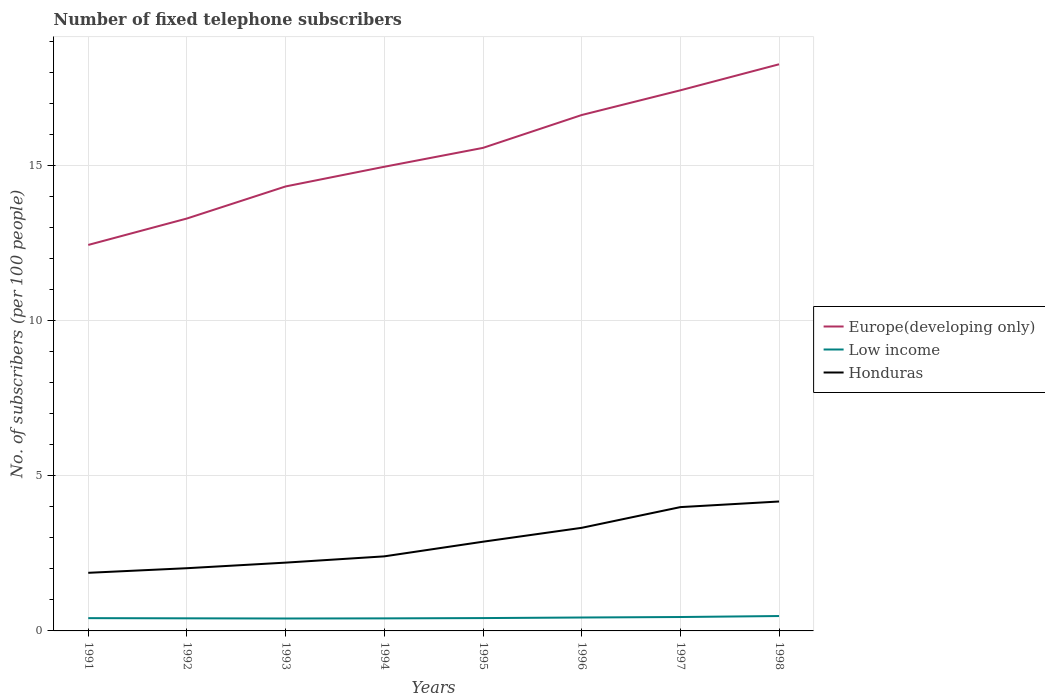How many different coloured lines are there?
Ensure brevity in your answer.  3. Does the line corresponding to Low income intersect with the line corresponding to Honduras?
Offer a terse response. No. Across all years, what is the maximum number of fixed telephone subscribers in Europe(developing only)?
Your answer should be very brief. 12.44. In which year was the number of fixed telephone subscribers in Europe(developing only) maximum?
Give a very brief answer. 1991. What is the total number of fixed telephone subscribers in Low income in the graph?
Ensure brevity in your answer.  -0. What is the difference between the highest and the second highest number of fixed telephone subscribers in Low income?
Ensure brevity in your answer.  0.08. What is the difference between the highest and the lowest number of fixed telephone subscribers in Low income?
Your answer should be compact. 3. Is the number of fixed telephone subscribers in Europe(developing only) strictly greater than the number of fixed telephone subscribers in Honduras over the years?
Offer a terse response. No. Are the values on the major ticks of Y-axis written in scientific E-notation?
Offer a terse response. No. Does the graph contain grids?
Give a very brief answer. Yes. How many legend labels are there?
Ensure brevity in your answer.  3. How are the legend labels stacked?
Ensure brevity in your answer.  Vertical. What is the title of the graph?
Make the answer very short. Number of fixed telephone subscribers. Does "Burkina Faso" appear as one of the legend labels in the graph?
Your answer should be compact. No. What is the label or title of the X-axis?
Your response must be concise. Years. What is the label or title of the Y-axis?
Provide a short and direct response. No. of subscribers (per 100 people). What is the No. of subscribers (per 100 people) in Europe(developing only) in 1991?
Ensure brevity in your answer.  12.44. What is the No. of subscribers (per 100 people) of Low income in 1991?
Make the answer very short. 0.41. What is the No. of subscribers (per 100 people) of Honduras in 1991?
Ensure brevity in your answer.  1.87. What is the No. of subscribers (per 100 people) in Europe(developing only) in 1992?
Offer a very short reply. 13.29. What is the No. of subscribers (per 100 people) of Low income in 1992?
Give a very brief answer. 0.41. What is the No. of subscribers (per 100 people) of Honduras in 1992?
Give a very brief answer. 2.02. What is the No. of subscribers (per 100 people) of Europe(developing only) in 1993?
Offer a terse response. 14.33. What is the No. of subscribers (per 100 people) in Low income in 1993?
Ensure brevity in your answer.  0.4. What is the No. of subscribers (per 100 people) of Honduras in 1993?
Your answer should be compact. 2.2. What is the No. of subscribers (per 100 people) of Europe(developing only) in 1994?
Your response must be concise. 14.96. What is the No. of subscribers (per 100 people) in Low income in 1994?
Provide a succinct answer. 0.4. What is the No. of subscribers (per 100 people) in Honduras in 1994?
Keep it short and to the point. 2.4. What is the No. of subscribers (per 100 people) in Europe(developing only) in 1995?
Make the answer very short. 15.57. What is the No. of subscribers (per 100 people) of Low income in 1995?
Make the answer very short. 0.41. What is the No. of subscribers (per 100 people) in Honduras in 1995?
Give a very brief answer. 2.88. What is the No. of subscribers (per 100 people) of Europe(developing only) in 1996?
Your response must be concise. 16.63. What is the No. of subscribers (per 100 people) in Low income in 1996?
Make the answer very short. 0.43. What is the No. of subscribers (per 100 people) of Honduras in 1996?
Provide a succinct answer. 3.32. What is the No. of subscribers (per 100 people) of Europe(developing only) in 1997?
Your answer should be compact. 17.43. What is the No. of subscribers (per 100 people) in Low income in 1997?
Ensure brevity in your answer.  0.45. What is the No. of subscribers (per 100 people) of Honduras in 1997?
Offer a terse response. 3.99. What is the No. of subscribers (per 100 people) of Europe(developing only) in 1998?
Provide a short and direct response. 18.27. What is the No. of subscribers (per 100 people) in Low income in 1998?
Provide a succinct answer. 0.48. What is the No. of subscribers (per 100 people) of Honduras in 1998?
Provide a succinct answer. 4.17. Across all years, what is the maximum No. of subscribers (per 100 people) in Europe(developing only)?
Give a very brief answer. 18.27. Across all years, what is the maximum No. of subscribers (per 100 people) in Low income?
Make the answer very short. 0.48. Across all years, what is the maximum No. of subscribers (per 100 people) in Honduras?
Your answer should be compact. 4.17. Across all years, what is the minimum No. of subscribers (per 100 people) of Europe(developing only)?
Ensure brevity in your answer.  12.44. Across all years, what is the minimum No. of subscribers (per 100 people) in Low income?
Keep it short and to the point. 0.4. Across all years, what is the minimum No. of subscribers (per 100 people) in Honduras?
Keep it short and to the point. 1.87. What is the total No. of subscribers (per 100 people) in Europe(developing only) in the graph?
Offer a very short reply. 122.92. What is the total No. of subscribers (per 100 people) in Low income in the graph?
Your response must be concise. 3.4. What is the total No. of subscribers (per 100 people) of Honduras in the graph?
Make the answer very short. 22.86. What is the difference between the No. of subscribers (per 100 people) of Europe(developing only) in 1991 and that in 1992?
Keep it short and to the point. -0.85. What is the difference between the No. of subscribers (per 100 people) of Low income in 1991 and that in 1992?
Offer a terse response. 0.01. What is the difference between the No. of subscribers (per 100 people) in Honduras in 1991 and that in 1992?
Your response must be concise. -0.15. What is the difference between the No. of subscribers (per 100 people) in Europe(developing only) in 1991 and that in 1993?
Provide a succinct answer. -1.89. What is the difference between the No. of subscribers (per 100 people) in Low income in 1991 and that in 1993?
Offer a terse response. 0.01. What is the difference between the No. of subscribers (per 100 people) of Honduras in 1991 and that in 1993?
Provide a succinct answer. -0.33. What is the difference between the No. of subscribers (per 100 people) of Europe(developing only) in 1991 and that in 1994?
Make the answer very short. -2.52. What is the difference between the No. of subscribers (per 100 people) in Low income in 1991 and that in 1994?
Your answer should be compact. 0.01. What is the difference between the No. of subscribers (per 100 people) of Honduras in 1991 and that in 1994?
Provide a short and direct response. -0.53. What is the difference between the No. of subscribers (per 100 people) of Europe(developing only) in 1991 and that in 1995?
Ensure brevity in your answer.  -3.13. What is the difference between the No. of subscribers (per 100 people) of Low income in 1991 and that in 1995?
Offer a terse response. -0. What is the difference between the No. of subscribers (per 100 people) in Honduras in 1991 and that in 1995?
Your response must be concise. -1. What is the difference between the No. of subscribers (per 100 people) in Europe(developing only) in 1991 and that in 1996?
Give a very brief answer. -4.19. What is the difference between the No. of subscribers (per 100 people) in Low income in 1991 and that in 1996?
Offer a terse response. -0.02. What is the difference between the No. of subscribers (per 100 people) in Honduras in 1991 and that in 1996?
Keep it short and to the point. -1.45. What is the difference between the No. of subscribers (per 100 people) in Europe(developing only) in 1991 and that in 1997?
Make the answer very short. -4.98. What is the difference between the No. of subscribers (per 100 people) of Low income in 1991 and that in 1997?
Keep it short and to the point. -0.04. What is the difference between the No. of subscribers (per 100 people) in Honduras in 1991 and that in 1997?
Provide a succinct answer. -2.12. What is the difference between the No. of subscribers (per 100 people) in Europe(developing only) in 1991 and that in 1998?
Offer a terse response. -5.82. What is the difference between the No. of subscribers (per 100 people) of Low income in 1991 and that in 1998?
Give a very brief answer. -0.07. What is the difference between the No. of subscribers (per 100 people) of Honduras in 1991 and that in 1998?
Keep it short and to the point. -2.3. What is the difference between the No. of subscribers (per 100 people) of Europe(developing only) in 1992 and that in 1993?
Give a very brief answer. -1.03. What is the difference between the No. of subscribers (per 100 people) in Low income in 1992 and that in 1993?
Provide a succinct answer. 0.01. What is the difference between the No. of subscribers (per 100 people) of Honduras in 1992 and that in 1993?
Offer a terse response. -0.18. What is the difference between the No. of subscribers (per 100 people) of Europe(developing only) in 1992 and that in 1994?
Provide a short and direct response. -1.67. What is the difference between the No. of subscribers (per 100 people) in Low income in 1992 and that in 1994?
Keep it short and to the point. 0. What is the difference between the No. of subscribers (per 100 people) in Honduras in 1992 and that in 1994?
Your answer should be compact. -0.38. What is the difference between the No. of subscribers (per 100 people) of Europe(developing only) in 1992 and that in 1995?
Your response must be concise. -2.28. What is the difference between the No. of subscribers (per 100 people) of Low income in 1992 and that in 1995?
Provide a succinct answer. -0.01. What is the difference between the No. of subscribers (per 100 people) of Honduras in 1992 and that in 1995?
Your answer should be compact. -0.85. What is the difference between the No. of subscribers (per 100 people) of Europe(developing only) in 1992 and that in 1996?
Make the answer very short. -3.34. What is the difference between the No. of subscribers (per 100 people) in Low income in 1992 and that in 1996?
Your answer should be very brief. -0.03. What is the difference between the No. of subscribers (per 100 people) in Honduras in 1992 and that in 1996?
Offer a very short reply. -1.3. What is the difference between the No. of subscribers (per 100 people) in Europe(developing only) in 1992 and that in 1997?
Ensure brevity in your answer.  -4.13. What is the difference between the No. of subscribers (per 100 people) of Low income in 1992 and that in 1997?
Provide a short and direct response. -0.04. What is the difference between the No. of subscribers (per 100 people) in Honduras in 1992 and that in 1997?
Give a very brief answer. -1.97. What is the difference between the No. of subscribers (per 100 people) of Europe(developing only) in 1992 and that in 1998?
Provide a short and direct response. -4.97. What is the difference between the No. of subscribers (per 100 people) of Low income in 1992 and that in 1998?
Your answer should be compact. -0.07. What is the difference between the No. of subscribers (per 100 people) in Honduras in 1992 and that in 1998?
Provide a short and direct response. -2.15. What is the difference between the No. of subscribers (per 100 people) of Europe(developing only) in 1993 and that in 1994?
Keep it short and to the point. -0.63. What is the difference between the No. of subscribers (per 100 people) of Low income in 1993 and that in 1994?
Your answer should be compact. -0. What is the difference between the No. of subscribers (per 100 people) in Honduras in 1993 and that in 1994?
Give a very brief answer. -0.2. What is the difference between the No. of subscribers (per 100 people) of Europe(developing only) in 1993 and that in 1995?
Your response must be concise. -1.24. What is the difference between the No. of subscribers (per 100 people) of Low income in 1993 and that in 1995?
Make the answer very short. -0.01. What is the difference between the No. of subscribers (per 100 people) in Honduras in 1993 and that in 1995?
Your answer should be very brief. -0.67. What is the difference between the No. of subscribers (per 100 people) of Europe(developing only) in 1993 and that in 1996?
Your response must be concise. -2.3. What is the difference between the No. of subscribers (per 100 people) in Low income in 1993 and that in 1996?
Your answer should be very brief. -0.03. What is the difference between the No. of subscribers (per 100 people) of Honduras in 1993 and that in 1996?
Provide a short and direct response. -1.12. What is the difference between the No. of subscribers (per 100 people) in Europe(developing only) in 1993 and that in 1997?
Offer a terse response. -3.1. What is the difference between the No. of subscribers (per 100 people) in Low income in 1993 and that in 1997?
Your answer should be very brief. -0.05. What is the difference between the No. of subscribers (per 100 people) of Honduras in 1993 and that in 1997?
Provide a short and direct response. -1.79. What is the difference between the No. of subscribers (per 100 people) of Europe(developing only) in 1993 and that in 1998?
Provide a short and direct response. -3.94. What is the difference between the No. of subscribers (per 100 people) in Low income in 1993 and that in 1998?
Offer a terse response. -0.08. What is the difference between the No. of subscribers (per 100 people) in Honduras in 1993 and that in 1998?
Keep it short and to the point. -1.97. What is the difference between the No. of subscribers (per 100 people) in Europe(developing only) in 1994 and that in 1995?
Your answer should be very brief. -0.61. What is the difference between the No. of subscribers (per 100 people) of Low income in 1994 and that in 1995?
Provide a succinct answer. -0.01. What is the difference between the No. of subscribers (per 100 people) in Honduras in 1994 and that in 1995?
Provide a succinct answer. -0.47. What is the difference between the No. of subscribers (per 100 people) in Europe(developing only) in 1994 and that in 1996?
Offer a very short reply. -1.67. What is the difference between the No. of subscribers (per 100 people) of Low income in 1994 and that in 1996?
Ensure brevity in your answer.  -0.03. What is the difference between the No. of subscribers (per 100 people) of Honduras in 1994 and that in 1996?
Keep it short and to the point. -0.92. What is the difference between the No. of subscribers (per 100 people) of Europe(developing only) in 1994 and that in 1997?
Your response must be concise. -2.46. What is the difference between the No. of subscribers (per 100 people) of Low income in 1994 and that in 1997?
Your answer should be compact. -0.04. What is the difference between the No. of subscribers (per 100 people) in Honduras in 1994 and that in 1997?
Provide a succinct answer. -1.59. What is the difference between the No. of subscribers (per 100 people) of Europe(developing only) in 1994 and that in 1998?
Your answer should be compact. -3.3. What is the difference between the No. of subscribers (per 100 people) in Low income in 1994 and that in 1998?
Provide a succinct answer. -0.08. What is the difference between the No. of subscribers (per 100 people) in Honduras in 1994 and that in 1998?
Offer a terse response. -1.77. What is the difference between the No. of subscribers (per 100 people) of Europe(developing only) in 1995 and that in 1996?
Your answer should be very brief. -1.06. What is the difference between the No. of subscribers (per 100 people) in Low income in 1995 and that in 1996?
Keep it short and to the point. -0.02. What is the difference between the No. of subscribers (per 100 people) of Honduras in 1995 and that in 1996?
Make the answer very short. -0.45. What is the difference between the No. of subscribers (per 100 people) of Europe(developing only) in 1995 and that in 1997?
Your answer should be very brief. -1.86. What is the difference between the No. of subscribers (per 100 people) in Low income in 1995 and that in 1997?
Keep it short and to the point. -0.03. What is the difference between the No. of subscribers (per 100 people) of Honduras in 1995 and that in 1997?
Provide a short and direct response. -1.12. What is the difference between the No. of subscribers (per 100 people) of Europe(developing only) in 1995 and that in 1998?
Your answer should be compact. -2.69. What is the difference between the No. of subscribers (per 100 people) in Low income in 1995 and that in 1998?
Provide a succinct answer. -0.07. What is the difference between the No. of subscribers (per 100 people) in Honduras in 1995 and that in 1998?
Your response must be concise. -1.3. What is the difference between the No. of subscribers (per 100 people) in Europe(developing only) in 1996 and that in 1997?
Give a very brief answer. -0.8. What is the difference between the No. of subscribers (per 100 people) of Low income in 1996 and that in 1997?
Your response must be concise. -0.02. What is the difference between the No. of subscribers (per 100 people) of Honduras in 1996 and that in 1997?
Offer a very short reply. -0.67. What is the difference between the No. of subscribers (per 100 people) in Europe(developing only) in 1996 and that in 1998?
Provide a short and direct response. -1.64. What is the difference between the No. of subscribers (per 100 people) in Low income in 1996 and that in 1998?
Your answer should be compact. -0.05. What is the difference between the No. of subscribers (per 100 people) in Honduras in 1996 and that in 1998?
Keep it short and to the point. -0.85. What is the difference between the No. of subscribers (per 100 people) of Europe(developing only) in 1997 and that in 1998?
Your response must be concise. -0.84. What is the difference between the No. of subscribers (per 100 people) in Low income in 1997 and that in 1998?
Provide a short and direct response. -0.03. What is the difference between the No. of subscribers (per 100 people) of Honduras in 1997 and that in 1998?
Your response must be concise. -0.18. What is the difference between the No. of subscribers (per 100 people) of Europe(developing only) in 1991 and the No. of subscribers (per 100 people) of Low income in 1992?
Your answer should be very brief. 12.04. What is the difference between the No. of subscribers (per 100 people) of Europe(developing only) in 1991 and the No. of subscribers (per 100 people) of Honduras in 1992?
Give a very brief answer. 10.42. What is the difference between the No. of subscribers (per 100 people) of Low income in 1991 and the No. of subscribers (per 100 people) of Honduras in 1992?
Ensure brevity in your answer.  -1.61. What is the difference between the No. of subscribers (per 100 people) in Europe(developing only) in 1991 and the No. of subscribers (per 100 people) in Low income in 1993?
Provide a short and direct response. 12.04. What is the difference between the No. of subscribers (per 100 people) in Europe(developing only) in 1991 and the No. of subscribers (per 100 people) in Honduras in 1993?
Your answer should be compact. 10.24. What is the difference between the No. of subscribers (per 100 people) in Low income in 1991 and the No. of subscribers (per 100 people) in Honduras in 1993?
Make the answer very short. -1.79. What is the difference between the No. of subscribers (per 100 people) of Europe(developing only) in 1991 and the No. of subscribers (per 100 people) of Low income in 1994?
Give a very brief answer. 12.04. What is the difference between the No. of subscribers (per 100 people) in Europe(developing only) in 1991 and the No. of subscribers (per 100 people) in Honduras in 1994?
Give a very brief answer. 10.04. What is the difference between the No. of subscribers (per 100 people) in Low income in 1991 and the No. of subscribers (per 100 people) in Honduras in 1994?
Make the answer very short. -1.99. What is the difference between the No. of subscribers (per 100 people) of Europe(developing only) in 1991 and the No. of subscribers (per 100 people) of Low income in 1995?
Provide a succinct answer. 12.03. What is the difference between the No. of subscribers (per 100 people) in Europe(developing only) in 1991 and the No. of subscribers (per 100 people) in Honduras in 1995?
Keep it short and to the point. 9.57. What is the difference between the No. of subscribers (per 100 people) in Low income in 1991 and the No. of subscribers (per 100 people) in Honduras in 1995?
Make the answer very short. -2.46. What is the difference between the No. of subscribers (per 100 people) of Europe(developing only) in 1991 and the No. of subscribers (per 100 people) of Low income in 1996?
Your response must be concise. 12.01. What is the difference between the No. of subscribers (per 100 people) of Europe(developing only) in 1991 and the No. of subscribers (per 100 people) of Honduras in 1996?
Give a very brief answer. 9.12. What is the difference between the No. of subscribers (per 100 people) in Low income in 1991 and the No. of subscribers (per 100 people) in Honduras in 1996?
Offer a very short reply. -2.91. What is the difference between the No. of subscribers (per 100 people) in Europe(developing only) in 1991 and the No. of subscribers (per 100 people) in Low income in 1997?
Offer a very short reply. 11.99. What is the difference between the No. of subscribers (per 100 people) in Europe(developing only) in 1991 and the No. of subscribers (per 100 people) in Honduras in 1997?
Make the answer very short. 8.45. What is the difference between the No. of subscribers (per 100 people) in Low income in 1991 and the No. of subscribers (per 100 people) in Honduras in 1997?
Your answer should be very brief. -3.58. What is the difference between the No. of subscribers (per 100 people) of Europe(developing only) in 1991 and the No. of subscribers (per 100 people) of Low income in 1998?
Keep it short and to the point. 11.96. What is the difference between the No. of subscribers (per 100 people) in Europe(developing only) in 1991 and the No. of subscribers (per 100 people) in Honduras in 1998?
Give a very brief answer. 8.27. What is the difference between the No. of subscribers (per 100 people) in Low income in 1991 and the No. of subscribers (per 100 people) in Honduras in 1998?
Give a very brief answer. -3.76. What is the difference between the No. of subscribers (per 100 people) in Europe(developing only) in 1992 and the No. of subscribers (per 100 people) in Low income in 1993?
Give a very brief answer. 12.89. What is the difference between the No. of subscribers (per 100 people) in Europe(developing only) in 1992 and the No. of subscribers (per 100 people) in Honduras in 1993?
Your answer should be very brief. 11.09. What is the difference between the No. of subscribers (per 100 people) in Low income in 1992 and the No. of subscribers (per 100 people) in Honduras in 1993?
Make the answer very short. -1.8. What is the difference between the No. of subscribers (per 100 people) in Europe(developing only) in 1992 and the No. of subscribers (per 100 people) in Low income in 1994?
Make the answer very short. 12.89. What is the difference between the No. of subscribers (per 100 people) in Europe(developing only) in 1992 and the No. of subscribers (per 100 people) in Honduras in 1994?
Offer a terse response. 10.89. What is the difference between the No. of subscribers (per 100 people) of Low income in 1992 and the No. of subscribers (per 100 people) of Honduras in 1994?
Your answer should be compact. -2. What is the difference between the No. of subscribers (per 100 people) of Europe(developing only) in 1992 and the No. of subscribers (per 100 people) of Low income in 1995?
Offer a terse response. 12.88. What is the difference between the No. of subscribers (per 100 people) of Europe(developing only) in 1992 and the No. of subscribers (per 100 people) of Honduras in 1995?
Offer a very short reply. 10.42. What is the difference between the No. of subscribers (per 100 people) of Low income in 1992 and the No. of subscribers (per 100 people) of Honduras in 1995?
Offer a terse response. -2.47. What is the difference between the No. of subscribers (per 100 people) in Europe(developing only) in 1992 and the No. of subscribers (per 100 people) in Low income in 1996?
Provide a succinct answer. 12.86. What is the difference between the No. of subscribers (per 100 people) in Europe(developing only) in 1992 and the No. of subscribers (per 100 people) in Honduras in 1996?
Offer a very short reply. 9.97. What is the difference between the No. of subscribers (per 100 people) of Low income in 1992 and the No. of subscribers (per 100 people) of Honduras in 1996?
Your response must be concise. -2.92. What is the difference between the No. of subscribers (per 100 people) in Europe(developing only) in 1992 and the No. of subscribers (per 100 people) in Low income in 1997?
Your answer should be very brief. 12.85. What is the difference between the No. of subscribers (per 100 people) in Europe(developing only) in 1992 and the No. of subscribers (per 100 people) in Honduras in 1997?
Give a very brief answer. 9.3. What is the difference between the No. of subscribers (per 100 people) in Low income in 1992 and the No. of subscribers (per 100 people) in Honduras in 1997?
Make the answer very short. -3.59. What is the difference between the No. of subscribers (per 100 people) in Europe(developing only) in 1992 and the No. of subscribers (per 100 people) in Low income in 1998?
Give a very brief answer. 12.81. What is the difference between the No. of subscribers (per 100 people) in Europe(developing only) in 1992 and the No. of subscribers (per 100 people) in Honduras in 1998?
Give a very brief answer. 9.12. What is the difference between the No. of subscribers (per 100 people) in Low income in 1992 and the No. of subscribers (per 100 people) in Honduras in 1998?
Ensure brevity in your answer.  -3.77. What is the difference between the No. of subscribers (per 100 people) of Europe(developing only) in 1993 and the No. of subscribers (per 100 people) of Low income in 1994?
Your answer should be compact. 13.92. What is the difference between the No. of subscribers (per 100 people) in Europe(developing only) in 1993 and the No. of subscribers (per 100 people) in Honduras in 1994?
Provide a short and direct response. 11.92. What is the difference between the No. of subscribers (per 100 people) of Low income in 1993 and the No. of subscribers (per 100 people) of Honduras in 1994?
Offer a very short reply. -2. What is the difference between the No. of subscribers (per 100 people) of Europe(developing only) in 1993 and the No. of subscribers (per 100 people) of Low income in 1995?
Offer a terse response. 13.91. What is the difference between the No. of subscribers (per 100 people) of Europe(developing only) in 1993 and the No. of subscribers (per 100 people) of Honduras in 1995?
Offer a very short reply. 11.45. What is the difference between the No. of subscribers (per 100 people) in Low income in 1993 and the No. of subscribers (per 100 people) in Honduras in 1995?
Offer a very short reply. -2.48. What is the difference between the No. of subscribers (per 100 people) of Europe(developing only) in 1993 and the No. of subscribers (per 100 people) of Low income in 1996?
Offer a very short reply. 13.9. What is the difference between the No. of subscribers (per 100 people) of Europe(developing only) in 1993 and the No. of subscribers (per 100 people) of Honduras in 1996?
Your response must be concise. 11. What is the difference between the No. of subscribers (per 100 people) of Low income in 1993 and the No. of subscribers (per 100 people) of Honduras in 1996?
Provide a short and direct response. -2.92. What is the difference between the No. of subscribers (per 100 people) of Europe(developing only) in 1993 and the No. of subscribers (per 100 people) of Low income in 1997?
Make the answer very short. 13.88. What is the difference between the No. of subscribers (per 100 people) in Europe(developing only) in 1993 and the No. of subscribers (per 100 people) in Honduras in 1997?
Provide a succinct answer. 10.34. What is the difference between the No. of subscribers (per 100 people) in Low income in 1993 and the No. of subscribers (per 100 people) in Honduras in 1997?
Your answer should be compact. -3.59. What is the difference between the No. of subscribers (per 100 people) of Europe(developing only) in 1993 and the No. of subscribers (per 100 people) of Low income in 1998?
Provide a short and direct response. 13.85. What is the difference between the No. of subscribers (per 100 people) in Europe(developing only) in 1993 and the No. of subscribers (per 100 people) in Honduras in 1998?
Provide a succinct answer. 10.16. What is the difference between the No. of subscribers (per 100 people) of Low income in 1993 and the No. of subscribers (per 100 people) of Honduras in 1998?
Your response must be concise. -3.77. What is the difference between the No. of subscribers (per 100 people) of Europe(developing only) in 1994 and the No. of subscribers (per 100 people) of Low income in 1995?
Provide a short and direct response. 14.55. What is the difference between the No. of subscribers (per 100 people) in Europe(developing only) in 1994 and the No. of subscribers (per 100 people) in Honduras in 1995?
Your answer should be very brief. 12.09. What is the difference between the No. of subscribers (per 100 people) in Low income in 1994 and the No. of subscribers (per 100 people) in Honduras in 1995?
Provide a succinct answer. -2.47. What is the difference between the No. of subscribers (per 100 people) of Europe(developing only) in 1994 and the No. of subscribers (per 100 people) of Low income in 1996?
Offer a very short reply. 14.53. What is the difference between the No. of subscribers (per 100 people) in Europe(developing only) in 1994 and the No. of subscribers (per 100 people) in Honduras in 1996?
Provide a short and direct response. 11.64. What is the difference between the No. of subscribers (per 100 people) in Low income in 1994 and the No. of subscribers (per 100 people) in Honduras in 1996?
Ensure brevity in your answer.  -2.92. What is the difference between the No. of subscribers (per 100 people) of Europe(developing only) in 1994 and the No. of subscribers (per 100 people) of Low income in 1997?
Your response must be concise. 14.51. What is the difference between the No. of subscribers (per 100 people) of Europe(developing only) in 1994 and the No. of subscribers (per 100 people) of Honduras in 1997?
Provide a short and direct response. 10.97. What is the difference between the No. of subscribers (per 100 people) in Low income in 1994 and the No. of subscribers (per 100 people) in Honduras in 1997?
Your answer should be very brief. -3.59. What is the difference between the No. of subscribers (per 100 people) of Europe(developing only) in 1994 and the No. of subscribers (per 100 people) of Low income in 1998?
Give a very brief answer. 14.48. What is the difference between the No. of subscribers (per 100 people) in Europe(developing only) in 1994 and the No. of subscribers (per 100 people) in Honduras in 1998?
Keep it short and to the point. 10.79. What is the difference between the No. of subscribers (per 100 people) in Low income in 1994 and the No. of subscribers (per 100 people) in Honduras in 1998?
Keep it short and to the point. -3.77. What is the difference between the No. of subscribers (per 100 people) of Europe(developing only) in 1995 and the No. of subscribers (per 100 people) of Low income in 1996?
Keep it short and to the point. 15.14. What is the difference between the No. of subscribers (per 100 people) in Europe(developing only) in 1995 and the No. of subscribers (per 100 people) in Honduras in 1996?
Make the answer very short. 12.25. What is the difference between the No. of subscribers (per 100 people) in Low income in 1995 and the No. of subscribers (per 100 people) in Honduras in 1996?
Your answer should be compact. -2.91. What is the difference between the No. of subscribers (per 100 people) of Europe(developing only) in 1995 and the No. of subscribers (per 100 people) of Low income in 1997?
Provide a succinct answer. 15.12. What is the difference between the No. of subscribers (per 100 people) in Europe(developing only) in 1995 and the No. of subscribers (per 100 people) in Honduras in 1997?
Ensure brevity in your answer.  11.58. What is the difference between the No. of subscribers (per 100 people) in Low income in 1995 and the No. of subscribers (per 100 people) in Honduras in 1997?
Your response must be concise. -3.58. What is the difference between the No. of subscribers (per 100 people) of Europe(developing only) in 1995 and the No. of subscribers (per 100 people) of Low income in 1998?
Your answer should be compact. 15.09. What is the difference between the No. of subscribers (per 100 people) in Europe(developing only) in 1995 and the No. of subscribers (per 100 people) in Honduras in 1998?
Your answer should be compact. 11.4. What is the difference between the No. of subscribers (per 100 people) in Low income in 1995 and the No. of subscribers (per 100 people) in Honduras in 1998?
Ensure brevity in your answer.  -3.76. What is the difference between the No. of subscribers (per 100 people) of Europe(developing only) in 1996 and the No. of subscribers (per 100 people) of Low income in 1997?
Offer a terse response. 16.18. What is the difference between the No. of subscribers (per 100 people) in Europe(developing only) in 1996 and the No. of subscribers (per 100 people) in Honduras in 1997?
Offer a very short reply. 12.64. What is the difference between the No. of subscribers (per 100 people) in Low income in 1996 and the No. of subscribers (per 100 people) in Honduras in 1997?
Your answer should be very brief. -3.56. What is the difference between the No. of subscribers (per 100 people) of Europe(developing only) in 1996 and the No. of subscribers (per 100 people) of Low income in 1998?
Keep it short and to the point. 16.15. What is the difference between the No. of subscribers (per 100 people) of Europe(developing only) in 1996 and the No. of subscribers (per 100 people) of Honduras in 1998?
Ensure brevity in your answer.  12.46. What is the difference between the No. of subscribers (per 100 people) in Low income in 1996 and the No. of subscribers (per 100 people) in Honduras in 1998?
Your response must be concise. -3.74. What is the difference between the No. of subscribers (per 100 people) of Europe(developing only) in 1997 and the No. of subscribers (per 100 people) of Low income in 1998?
Offer a terse response. 16.95. What is the difference between the No. of subscribers (per 100 people) in Europe(developing only) in 1997 and the No. of subscribers (per 100 people) in Honduras in 1998?
Provide a short and direct response. 13.26. What is the difference between the No. of subscribers (per 100 people) of Low income in 1997 and the No. of subscribers (per 100 people) of Honduras in 1998?
Keep it short and to the point. -3.72. What is the average No. of subscribers (per 100 people) of Europe(developing only) per year?
Your answer should be compact. 15.37. What is the average No. of subscribers (per 100 people) in Low income per year?
Your answer should be compact. 0.42. What is the average No. of subscribers (per 100 people) in Honduras per year?
Provide a succinct answer. 2.86. In the year 1991, what is the difference between the No. of subscribers (per 100 people) in Europe(developing only) and No. of subscribers (per 100 people) in Low income?
Offer a terse response. 12.03. In the year 1991, what is the difference between the No. of subscribers (per 100 people) in Europe(developing only) and No. of subscribers (per 100 people) in Honduras?
Ensure brevity in your answer.  10.57. In the year 1991, what is the difference between the No. of subscribers (per 100 people) of Low income and No. of subscribers (per 100 people) of Honduras?
Your answer should be compact. -1.46. In the year 1992, what is the difference between the No. of subscribers (per 100 people) in Europe(developing only) and No. of subscribers (per 100 people) in Low income?
Your response must be concise. 12.89. In the year 1992, what is the difference between the No. of subscribers (per 100 people) of Europe(developing only) and No. of subscribers (per 100 people) of Honduras?
Offer a terse response. 11.27. In the year 1992, what is the difference between the No. of subscribers (per 100 people) of Low income and No. of subscribers (per 100 people) of Honduras?
Offer a terse response. -1.62. In the year 1993, what is the difference between the No. of subscribers (per 100 people) of Europe(developing only) and No. of subscribers (per 100 people) of Low income?
Ensure brevity in your answer.  13.93. In the year 1993, what is the difference between the No. of subscribers (per 100 people) of Europe(developing only) and No. of subscribers (per 100 people) of Honduras?
Your answer should be very brief. 12.13. In the year 1993, what is the difference between the No. of subscribers (per 100 people) of Low income and No. of subscribers (per 100 people) of Honduras?
Your answer should be very brief. -1.8. In the year 1994, what is the difference between the No. of subscribers (per 100 people) of Europe(developing only) and No. of subscribers (per 100 people) of Low income?
Your answer should be compact. 14.56. In the year 1994, what is the difference between the No. of subscribers (per 100 people) in Europe(developing only) and No. of subscribers (per 100 people) in Honduras?
Your answer should be compact. 12.56. In the year 1994, what is the difference between the No. of subscribers (per 100 people) in Low income and No. of subscribers (per 100 people) in Honduras?
Keep it short and to the point. -2. In the year 1995, what is the difference between the No. of subscribers (per 100 people) in Europe(developing only) and No. of subscribers (per 100 people) in Low income?
Your response must be concise. 15.16. In the year 1995, what is the difference between the No. of subscribers (per 100 people) in Europe(developing only) and No. of subscribers (per 100 people) in Honduras?
Your answer should be very brief. 12.7. In the year 1995, what is the difference between the No. of subscribers (per 100 people) in Low income and No. of subscribers (per 100 people) in Honduras?
Make the answer very short. -2.46. In the year 1996, what is the difference between the No. of subscribers (per 100 people) of Europe(developing only) and No. of subscribers (per 100 people) of Low income?
Offer a very short reply. 16.2. In the year 1996, what is the difference between the No. of subscribers (per 100 people) of Europe(developing only) and No. of subscribers (per 100 people) of Honduras?
Give a very brief answer. 13.31. In the year 1996, what is the difference between the No. of subscribers (per 100 people) in Low income and No. of subscribers (per 100 people) in Honduras?
Offer a terse response. -2.89. In the year 1997, what is the difference between the No. of subscribers (per 100 people) in Europe(developing only) and No. of subscribers (per 100 people) in Low income?
Provide a short and direct response. 16.98. In the year 1997, what is the difference between the No. of subscribers (per 100 people) of Europe(developing only) and No. of subscribers (per 100 people) of Honduras?
Your response must be concise. 13.44. In the year 1997, what is the difference between the No. of subscribers (per 100 people) in Low income and No. of subscribers (per 100 people) in Honduras?
Give a very brief answer. -3.54. In the year 1998, what is the difference between the No. of subscribers (per 100 people) in Europe(developing only) and No. of subscribers (per 100 people) in Low income?
Your answer should be very brief. 17.79. In the year 1998, what is the difference between the No. of subscribers (per 100 people) of Europe(developing only) and No. of subscribers (per 100 people) of Honduras?
Give a very brief answer. 14.09. In the year 1998, what is the difference between the No. of subscribers (per 100 people) of Low income and No. of subscribers (per 100 people) of Honduras?
Your response must be concise. -3.69. What is the ratio of the No. of subscribers (per 100 people) in Europe(developing only) in 1991 to that in 1992?
Provide a short and direct response. 0.94. What is the ratio of the No. of subscribers (per 100 people) of Low income in 1991 to that in 1992?
Give a very brief answer. 1.01. What is the ratio of the No. of subscribers (per 100 people) of Honduras in 1991 to that in 1992?
Your answer should be very brief. 0.93. What is the ratio of the No. of subscribers (per 100 people) of Europe(developing only) in 1991 to that in 1993?
Provide a succinct answer. 0.87. What is the ratio of the No. of subscribers (per 100 people) of Low income in 1991 to that in 1993?
Offer a very short reply. 1.03. What is the ratio of the No. of subscribers (per 100 people) of Honduras in 1991 to that in 1993?
Provide a short and direct response. 0.85. What is the ratio of the No. of subscribers (per 100 people) of Europe(developing only) in 1991 to that in 1994?
Ensure brevity in your answer.  0.83. What is the ratio of the No. of subscribers (per 100 people) in Low income in 1991 to that in 1994?
Offer a very short reply. 1.02. What is the ratio of the No. of subscribers (per 100 people) of Honduras in 1991 to that in 1994?
Offer a very short reply. 0.78. What is the ratio of the No. of subscribers (per 100 people) in Europe(developing only) in 1991 to that in 1995?
Make the answer very short. 0.8. What is the ratio of the No. of subscribers (per 100 people) in Honduras in 1991 to that in 1995?
Provide a succinct answer. 0.65. What is the ratio of the No. of subscribers (per 100 people) of Europe(developing only) in 1991 to that in 1996?
Your answer should be very brief. 0.75. What is the ratio of the No. of subscribers (per 100 people) of Low income in 1991 to that in 1996?
Keep it short and to the point. 0.95. What is the ratio of the No. of subscribers (per 100 people) in Honduras in 1991 to that in 1996?
Ensure brevity in your answer.  0.56. What is the ratio of the No. of subscribers (per 100 people) of Europe(developing only) in 1991 to that in 1997?
Your answer should be very brief. 0.71. What is the ratio of the No. of subscribers (per 100 people) of Low income in 1991 to that in 1997?
Provide a short and direct response. 0.92. What is the ratio of the No. of subscribers (per 100 people) of Honduras in 1991 to that in 1997?
Your answer should be compact. 0.47. What is the ratio of the No. of subscribers (per 100 people) of Europe(developing only) in 1991 to that in 1998?
Ensure brevity in your answer.  0.68. What is the ratio of the No. of subscribers (per 100 people) of Low income in 1991 to that in 1998?
Your response must be concise. 0.86. What is the ratio of the No. of subscribers (per 100 people) of Honduras in 1991 to that in 1998?
Offer a very short reply. 0.45. What is the ratio of the No. of subscribers (per 100 people) in Europe(developing only) in 1992 to that in 1993?
Your answer should be compact. 0.93. What is the ratio of the No. of subscribers (per 100 people) in Low income in 1992 to that in 1993?
Your answer should be compact. 1.01. What is the ratio of the No. of subscribers (per 100 people) of Honduras in 1992 to that in 1993?
Your answer should be very brief. 0.92. What is the ratio of the No. of subscribers (per 100 people) of Europe(developing only) in 1992 to that in 1994?
Your answer should be very brief. 0.89. What is the ratio of the No. of subscribers (per 100 people) of Low income in 1992 to that in 1994?
Your answer should be compact. 1. What is the ratio of the No. of subscribers (per 100 people) of Honduras in 1992 to that in 1994?
Offer a terse response. 0.84. What is the ratio of the No. of subscribers (per 100 people) of Europe(developing only) in 1992 to that in 1995?
Provide a succinct answer. 0.85. What is the ratio of the No. of subscribers (per 100 people) of Low income in 1992 to that in 1995?
Your answer should be very brief. 0.98. What is the ratio of the No. of subscribers (per 100 people) in Honduras in 1992 to that in 1995?
Provide a succinct answer. 0.7. What is the ratio of the No. of subscribers (per 100 people) in Europe(developing only) in 1992 to that in 1996?
Give a very brief answer. 0.8. What is the ratio of the No. of subscribers (per 100 people) in Low income in 1992 to that in 1996?
Your response must be concise. 0.94. What is the ratio of the No. of subscribers (per 100 people) in Honduras in 1992 to that in 1996?
Offer a very short reply. 0.61. What is the ratio of the No. of subscribers (per 100 people) in Europe(developing only) in 1992 to that in 1997?
Your answer should be compact. 0.76. What is the ratio of the No. of subscribers (per 100 people) of Low income in 1992 to that in 1997?
Make the answer very short. 0.91. What is the ratio of the No. of subscribers (per 100 people) of Honduras in 1992 to that in 1997?
Ensure brevity in your answer.  0.51. What is the ratio of the No. of subscribers (per 100 people) of Europe(developing only) in 1992 to that in 1998?
Keep it short and to the point. 0.73. What is the ratio of the No. of subscribers (per 100 people) in Low income in 1992 to that in 1998?
Keep it short and to the point. 0.85. What is the ratio of the No. of subscribers (per 100 people) of Honduras in 1992 to that in 1998?
Your answer should be very brief. 0.48. What is the ratio of the No. of subscribers (per 100 people) of Europe(developing only) in 1993 to that in 1994?
Your answer should be very brief. 0.96. What is the ratio of the No. of subscribers (per 100 people) of Honduras in 1993 to that in 1994?
Your response must be concise. 0.92. What is the ratio of the No. of subscribers (per 100 people) of Europe(developing only) in 1993 to that in 1995?
Ensure brevity in your answer.  0.92. What is the ratio of the No. of subscribers (per 100 people) of Low income in 1993 to that in 1995?
Keep it short and to the point. 0.97. What is the ratio of the No. of subscribers (per 100 people) in Honduras in 1993 to that in 1995?
Your answer should be very brief. 0.77. What is the ratio of the No. of subscribers (per 100 people) in Europe(developing only) in 1993 to that in 1996?
Ensure brevity in your answer.  0.86. What is the ratio of the No. of subscribers (per 100 people) of Low income in 1993 to that in 1996?
Your response must be concise. 0.93. What is the ratio of the No. of subscribers (per 100 people) in Honduras in 1993 to that in 1996?
Your response must be concise. 0.66. What is the ratio of the No. of subscribers (per 100 people) in Europe(developing only) in 1993 to that in 1997?
Your response must be concise. 0.82. What is the ratio of the No. of subscribers (per 100 people) in Low income in 1993 to that in 1997?
Your answer should be compact. 0.89. What is the ratio of the No. of subscribers (per 100 people) of Honduras in 1993 to that in 1997?
Provide a short and direct response. 0.55. What is the ratio of the No. of subscribers (per 100 people) of Europe(developing only) in 1993 to that in 1998?
Keep it short and to the point. 0.78. What is the ratio of the No. of subscribers (per 100 people) of Low income in 1993 to that in 1998?
Provide a short and direct response. 0.83. What is the ratio of the No. of subscribers (per 100 people) in Honduras in 1993 to that in 1998?
Your answer should be compact. 0.53. What is the ratio of the No. of subscribers (per 100 people) in Europe(developing only) in 1994 to that in 1995?
Your answer should be very brief. 0.96. What is the ratio of the No. of subscribers (per 100 people) in Low income in 1994 to that in 1995?
Keep it short and to the point. 0.98. What is the ratio of the No. of subscribers (per 100 people) in Honduras in 1994 to that in 1995?
Keep it short and to the point. 0.84. What is the ratio of the No. of subscribers (per 100 people) of Europe(developing only) in 1994 to that in 1996?
Your answer should be compact. 0.9. What is the ratio of the No. of subscribers (per 100 people) of Low income in 1994 to that in 1996?
Offer a terse response. 0.94. What is the ratio of the No. of subscribers (per 100 people) in Honduras in 1994 to that in 1996?
Keep it short and to the point. 0.72. What is the ratio of the No. of subscribers (per 100 people) in Europe(developing only) in 1994 to that in 1997?
Your answer should be compact. 0.86. What is the ratio of the No. of subscribers (per 100 people) in Low income in 1994 to that in 1997?
Make the answer very short. 0.9. What is the ratio of the No. of subscribers (per 100 people) of Honduras in 1994 to that in 1997?
Your answer should be very brief. 0.6. What is the ratio of the No. of subscribers (per 100 people) in Europe(developing only) in 1994 to that in 1998?
Your answer should be very brief. 0.82. What is the ratio of the No. of subscribers (per 100 people) in Low income in 1994 to that in 1998?
Make the answer very short. 0.84. What is the ratio of the No. of subscribers (per 100 people) in Honduras in 1994 to that in 1998?
Your answer should be compact. 0.58. What is the ratio of the No. of subscribers (per 100 people) of Europe(developing only) in 1995 to that in 1996?
Keep it short and to the point. 0.94. What is the ratio of the No. of subscribers (per 100 people) in Low income in 1995 to that in 1996?
Ensure brevity in your answer.  0.96. What is the ratio of the No. of subscribers (per 100 people) of Honduras in 1995 to that in 1996?
Your answer should be very brief. 0.87. What is the ratio of the No. of subscribers (per 100 people) of Europe(developing only) in 1995 to that in 1997?
Your answer should be very brief. 0.89. What is the ratio of the No. of subscribers (per 100 people) in Low income in 1995 to that in 1997?
Give a very brief answer. 0.92. What is the ratio of the No. of subscribers (per 100 people) in Honduras in 1995 to that in 1997?
Make the answer very short. 0.72. What is the ratio of the No. of subscribers (per 100 people) of Europe(developing only) in 1995 to that in 1998?
Offer a very short reply. 0.85. What is the ratio of the No. of subscribers (per 100 people) of Low income in 1995 to that in 1998?
Your response must be concise. 0.86. What is the ratio of the No. of subscribers (per 100 people) in Honduras in 1995 to that in 1998?
Your answer should be compact. 0.69. What is the ratio of the No. of subscribers (per 100 people) of Europe(developing only) in 1996 to that in 1997?
Ensure brevity in your answer.  0.95. What is the ratio of the No. of subscribers (per 100 people) of Low income in 1996 to that in 1997?
Offer a terse response. 0.97. What is the ratio of the No. of subscribers (per 100 people) of Honduras in 1996 to that in 1997?
Ensure brevity in your answer.  0.83. What is the ratio of the No. of subscribers (per 100 people) in Europe(developing only) in 1996 to that in 1998?
Your response must be concise. 0.91. What is the ratio of the No. of subscribers (per 100 people) in Low income in 1996 to that in 1998?
Your answer should be very brief. 0.9. What is the ratio of the No. of subscribers (per 100 people) in Honduras in 1996 to that in 1998?
Provide a succinct answer. 0.8. What is the ratio of the No. of subscribers (per 100 people) of Europe(developing only) in 1997 to that in 1998?
Provide a short and direct response. 0.95. What is the ratio of the No. of subscribers (per 100 people) in Low income in 1997 to that in 1998?
Provide a short and direct response. 0.93. What is the ratio of the No. of subscribers (per 100 people) in Honduras in 1997 to that in 1998?
Make the answer very short. 0.96. What is the difference between the highest and the second highest No. of subscribers (per 100 people) in Europe(developing only)?
Your response must be concise. 0.84. What is the difference between the highest and the second highest No. of subscribers (per 100 people) of Low income?
Your response must be concise. 0.03. What is the difference between the highest and the second highest No. of subscribers (per 100 people) in Honduras?
Offer a very short reply. 0.18. What is the difference between the highest and the lowest No. of subscribers (per 100 people) in Europe(developing only)?
Keep it short and to the point. 5.82. What is the difference between the highest and the lowest No. of subscribers (per 100 people) in Low income?
Your answer should be very brief. 0.08. What is the difference between the highest and the lowest No. of subscribers (per 100 people) of Honduras?
Make the answer very short. 2.3. 